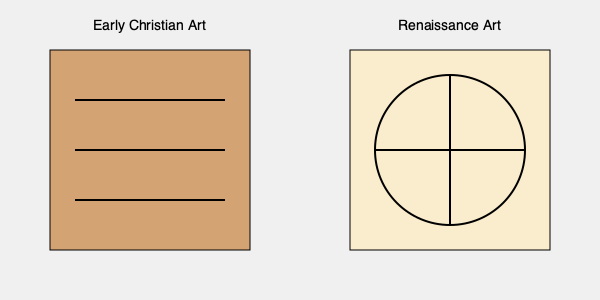How does the composition of a typical early Christian painting differ from that of a Renaissance work, and what does this reveal about the artistic constraints and freedoms of each period? 1. Early Christian Art Composition:
   - Characterized by rigid, horizontal layering
   - Often divided into distinct registers or bands
   - Figures arranged in a flat, frontal manner
   - Limited depth and perspective
   - Emphasis on symbolism and religious narrative

2. Renaissance Art Composition:
   - More dynamic and balanced arrangement
   - Use of geometric shapes, particularly the circle
   - Introduction of linear perspective
   - Greater depth and three-dimensionality
   - Focus on naturalism and human form

3. Comparison:
   - Early Christian art shows stricter adherence to religious themes
   - Renaissance art demonstrates more creative freedom in composition
   - Early Christian art emphasizes hierarchy and symbolism
   - Renaissance art focuses on realism and humanism

4. Artistic Constraints and Freedoms:
   - Early Christian art was limited by religious doctrine and the need for clear biblical narratives
   - Renaissance art benefited from a renewed interest in classical learning and scientific observation
   - Early Christian artists worked within a narrower range of acceptable subjects and styles
   - Renaissance artists had more liberty to explore new techniques and secular themes

5. Implications:
   - The shift from Early Christian to Renaissance art reflects broader cultural and philosophical changes
   - The loosening of religious constraints allowed for greater artistic innovation and experimentation
   - The Renaissance marked a transition from symbolic representation to more naturalistic depiction
Answer: Early Christian art shows rigid, symbolic composition due to religious constraints, while Renaissance art displays dynamic, naturalistic arrangement reflecting greater artistic freedom and humanism. 